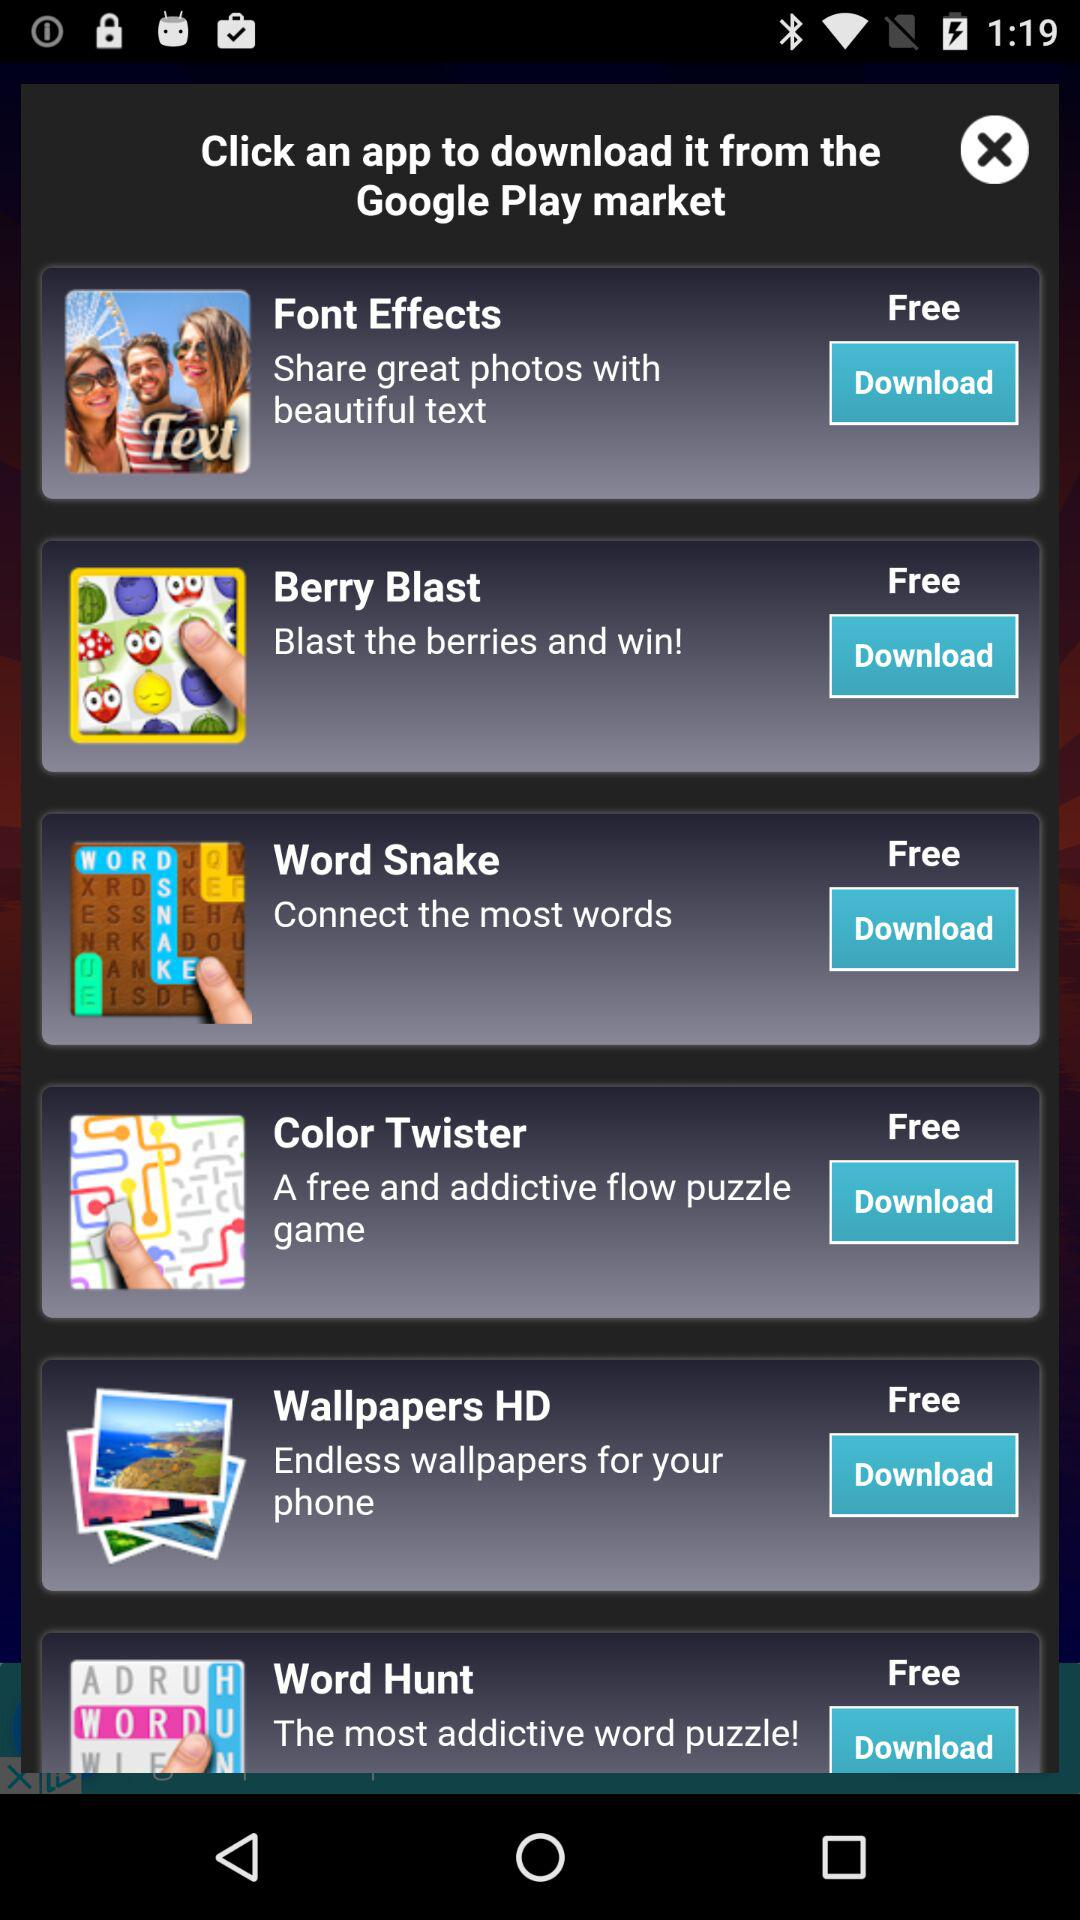How many apps are available for download?
Answer the question using a single word or phrase. 6 